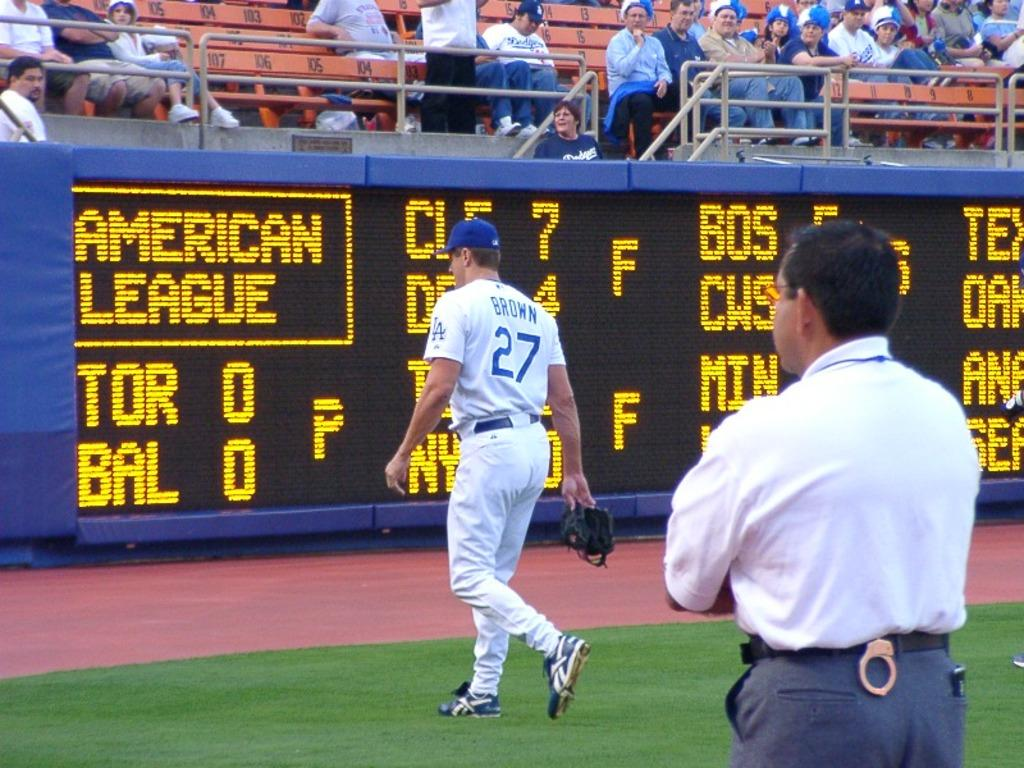<image>
Describe the image concisely. a man walking with American League written on the screen 